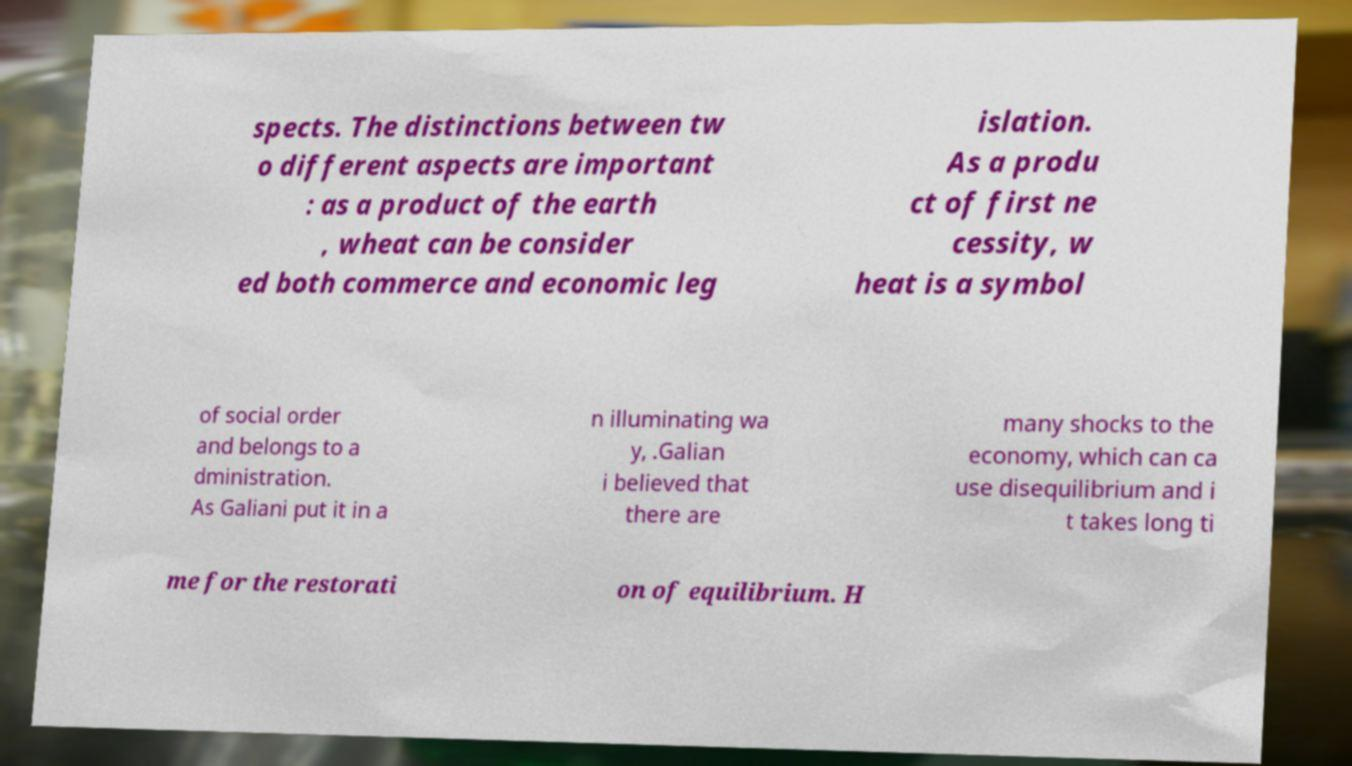I need the written content from this picture converted into text. Can you do that? spects. The distinctions between tw o different aspects are important : as a product of the earth , wheat can be consider ed both commerce and economic leg islation. As a produ ct of first ne cessity, w heat is a symbol of social order and belongs to a dministration. As Galiani put it in a n illuminating wa y, .Galian i believed that there are many shocks to the economy, which can ca use disequilibrium and i t takes long ti me for the restorati on of equilibrium. H 